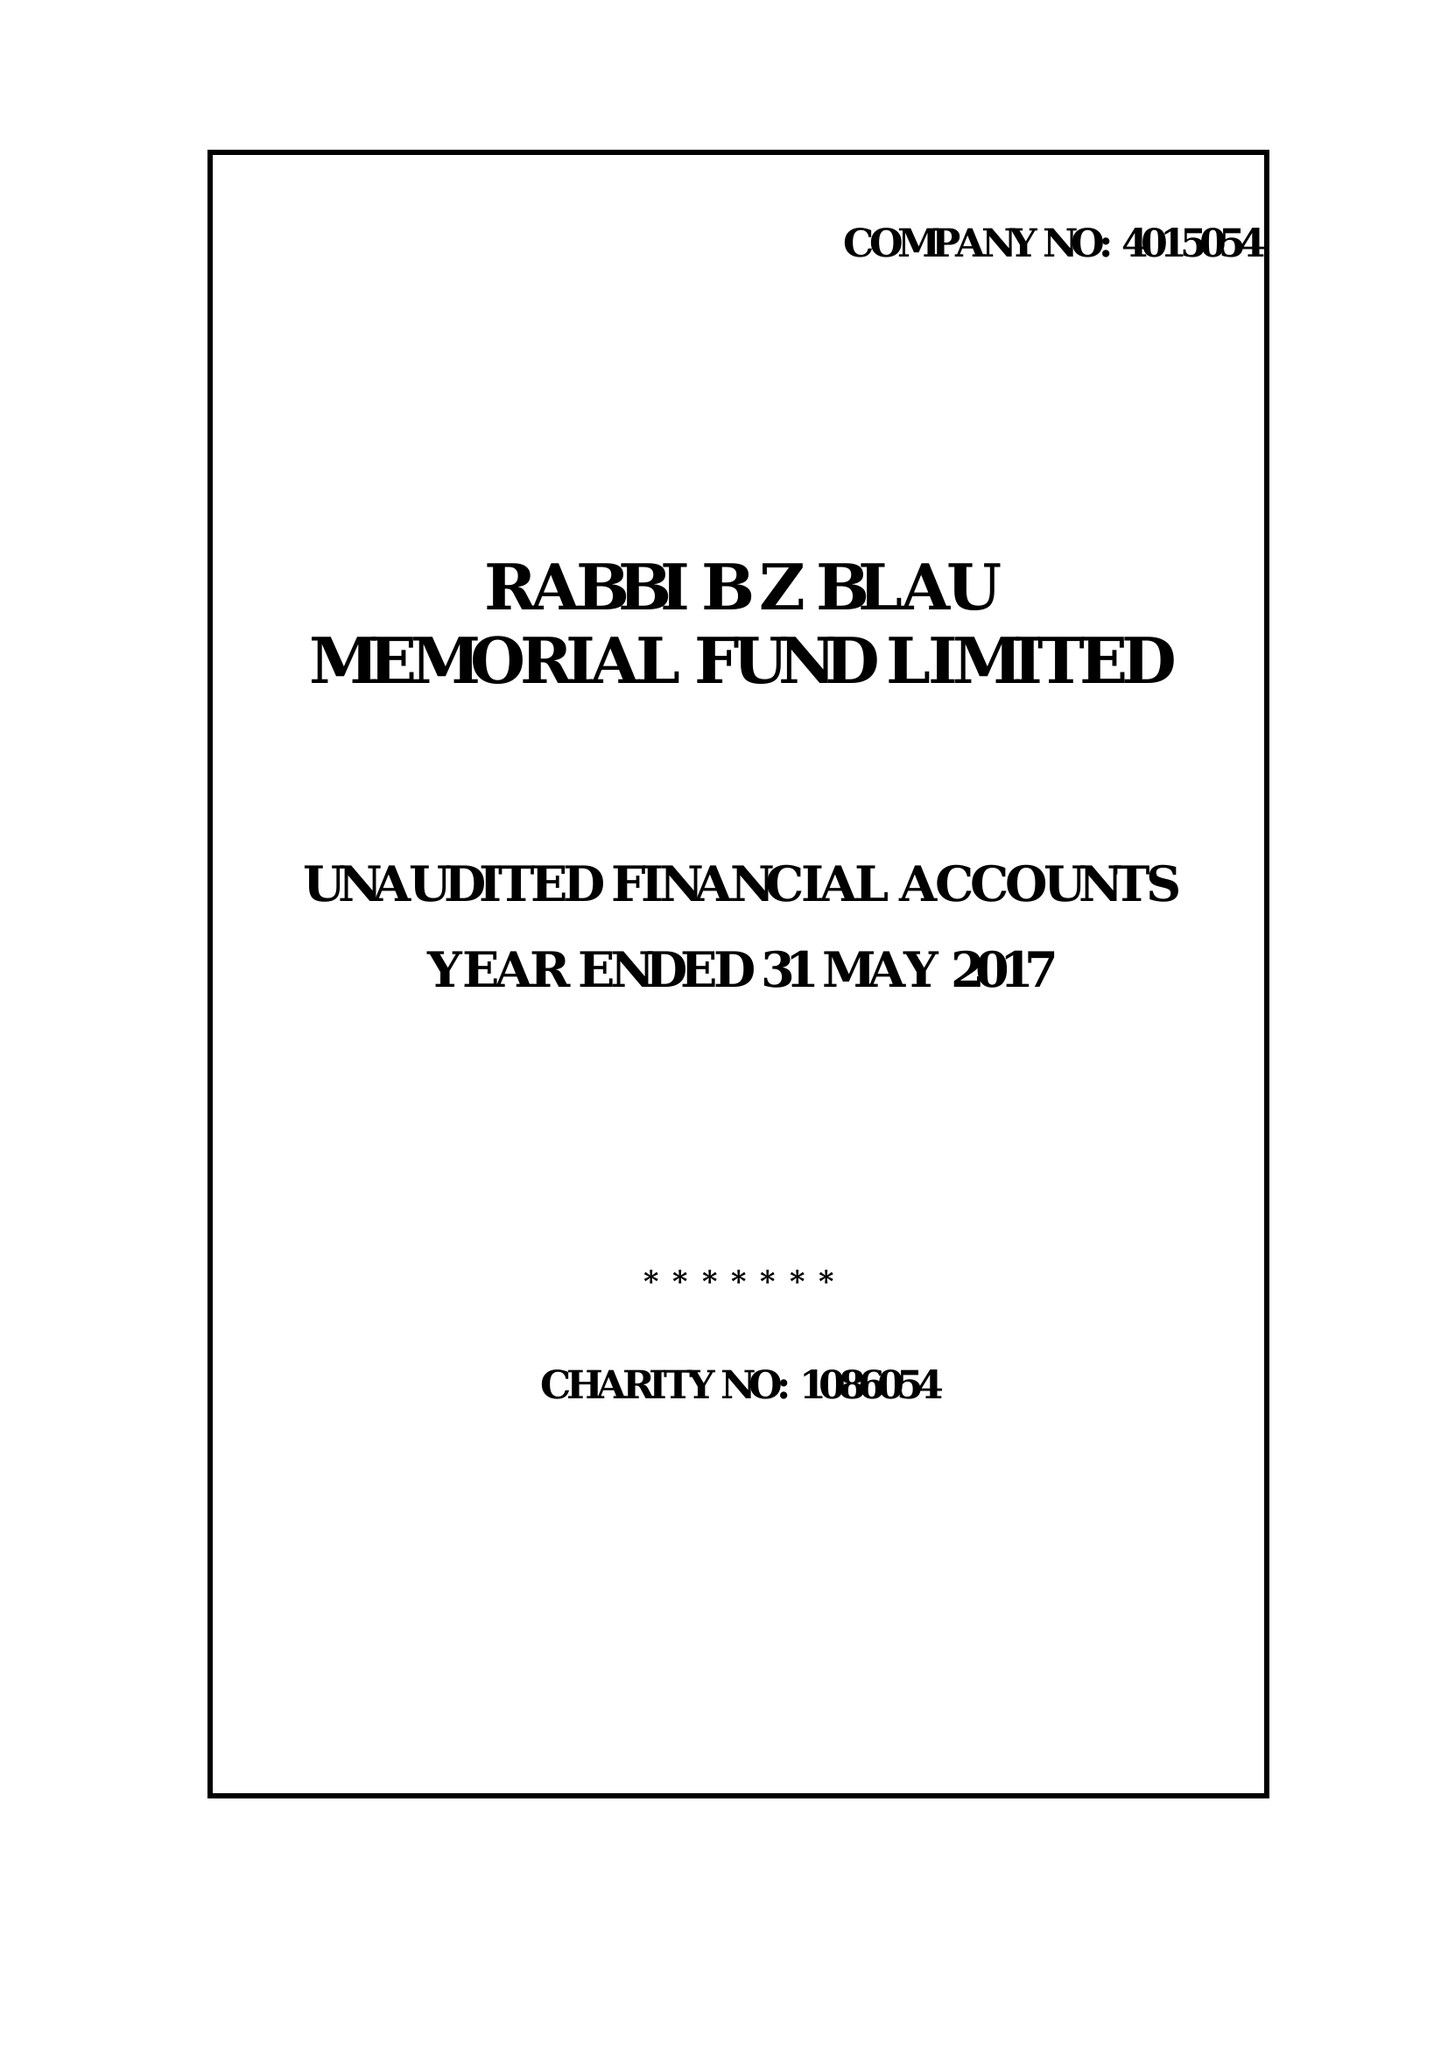What is the value for the address__postcode?
Answer the question using a single word or phrase. E5 9ND 